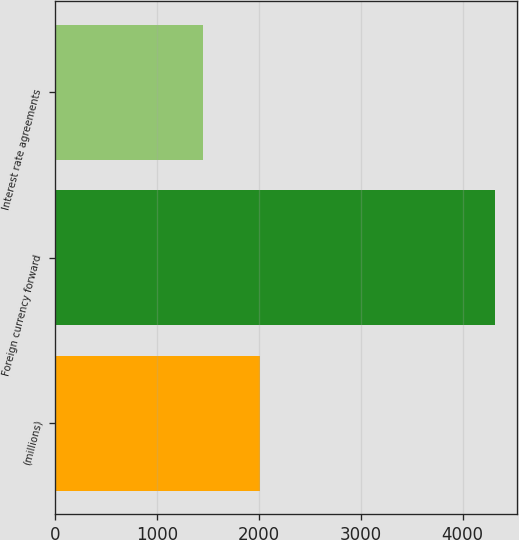<chart> <loc_0><loc_0><loc_500><loc_500><bar_chart><fcel>(millions)<fcel>Foreign currency forward<fcel>Interest rate agreements<nl><fcel>2016<fcel>4317<fcel>1450<nl></chart> 